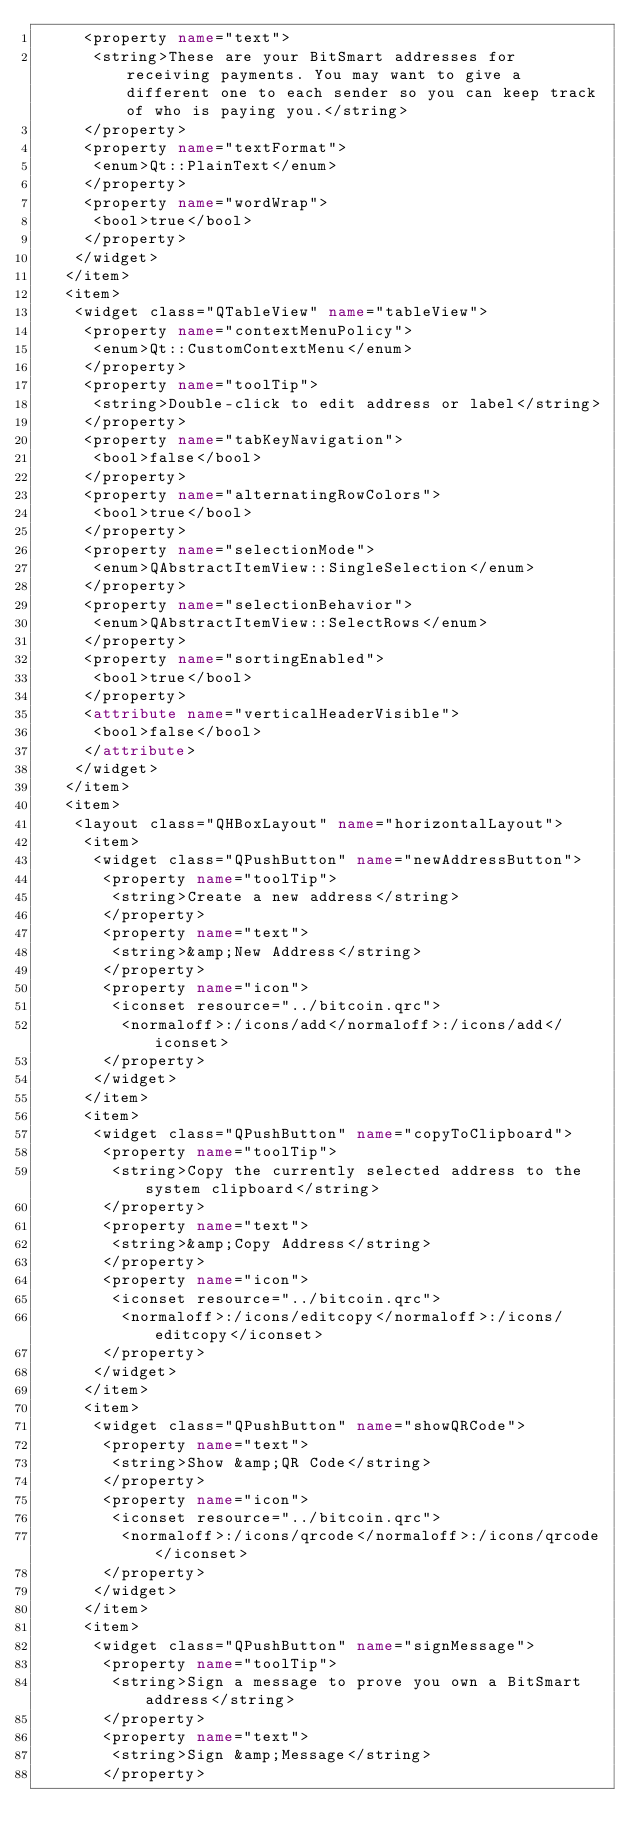<code> <loc_0><loc_0><loc_500><loc_500><_XML_>     <property name="text">
      <string>These are your BitSmart addresses for receiving payments. You may want to give a different one to each sender so you can keep track of who is paying you.</string>
     </property>
     <property name="textFormat">
      <enum>Qt::PlainText</enum>
     </property>
     <property name="wordWrap">
      <bool>true</bool>
     </property>
    </widget>
   </item>
   <item>
    <widget class="QTableView" name="tableView">
     <property name="contextMenuPolicy">
      <enum>Qt::CustomContextMenu</enum>
     </property>
     <property name="toolTip">
      <string>Double-click to edit address or label</string>
     </property>
     <property name="tabKeyNavigation">
      <bool>false</bool>
     </property>
     <property name="alternatingRowColors">
      <bool>true</bool>
     </property>
     <property name="selectionMode">
      <enum>QAbstractItemView::SingleSelection</enum>
     </property>
     <property name="selectionBehavior">
      <enum>QAbstractItemView::SelectRows</enum>
     </property>
     <property name="sortingEnabled">
      <bool>true</bool>
     </property>
     <attribute name="verticalHeaderVisible">
      <bool>false</bool>
     </attribute>
    </widget>
   </item>
   <item>
    <layout class="QHBoxLayout" name="horizontalLayout">
     <item>
      <widget class="QPushButton" name="newAddressButton">
       <property name="toolTip">
        <string>Create a new address</string>
       </property>
       <property name="text">
        <string>&amp;New Address</string>
       </property>
       <property name="icon">
        <iconset resource="../bitcoin.qrc">
         <normaloff>:/icons/add</normaloff>:/icons/add</iconset>
       </property>
      </widget>
     </item>
     <item>
      <widget class="QPushButton" name="copyToClipboard">
       <property name="toolTip">
        <string>Copy the currently selected address to the system clipboard</string>
       </property>
       <property name="text">
        <string>&amp;Copy Address</string>
       </property>
       <property name="icon">
        <iconset resource="../bitcoin.qrc">
         <normaloff>:/icons/editcopy</normaloff>:/icons/editcopy</iconset>
       </property>
      </widget>
     </item>
     <item>
      <widget class="QPushButton" name="showQRCode">
       <property name="text">
        <string>Show &amp;QR Code</string>
       </property>
       <property name="icon">
        <iconset resource="../bitcoin.qrc">
         <normaloff>:/icons/qrcode</normaloff>:/icons/qrcode</iconset>
       </property>
      </widget>
     </item>
     <item>
      <widget class="QPushButton" name="signMessage">
       <property name="toolTip">
        <string>Sign a message to prove you own a BitSmart address</string>
       </property>
       <property name="text">
        <string>Sign &amp;Message</string>
       </property></code> 